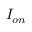Convert formula to latex. <formula><loc_0><loc_0><loc_500><loc_500>I _ { o n }</formula> 